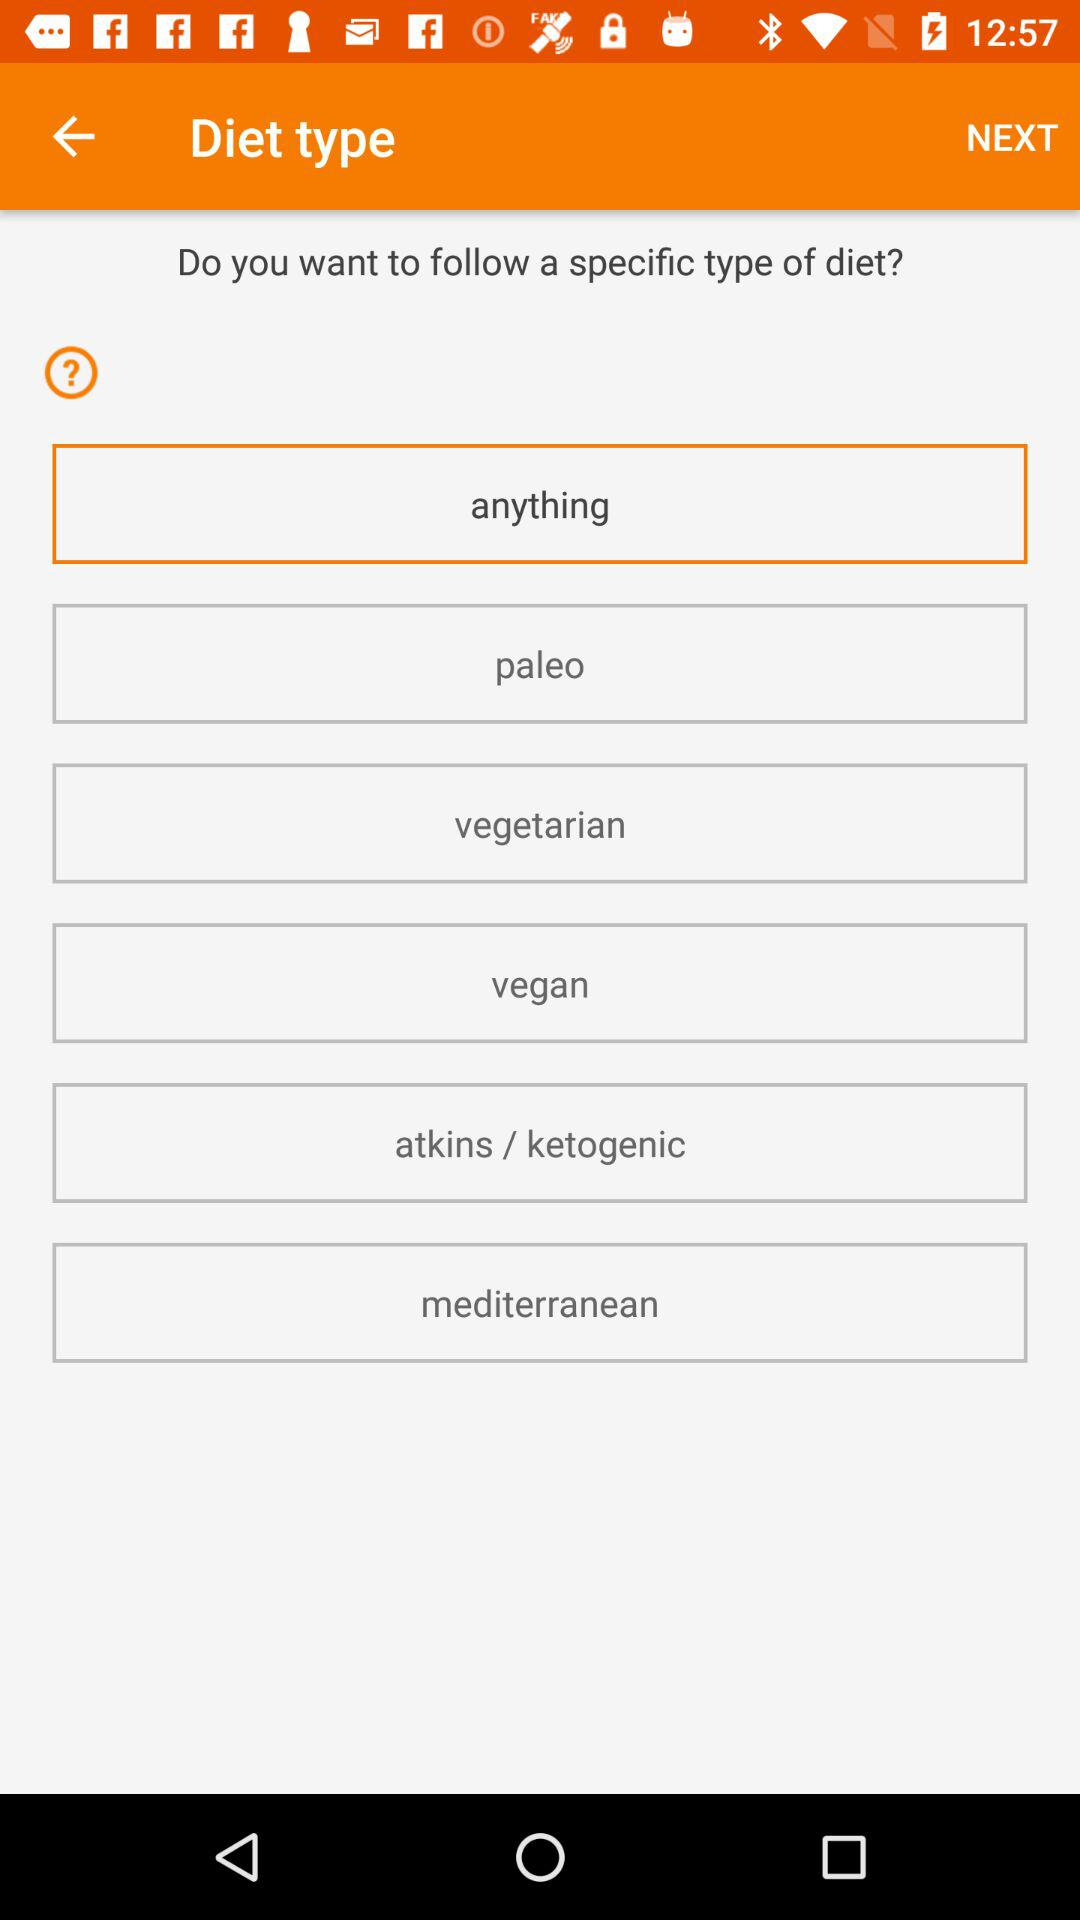How many diet types are there to choose from?
Answer the question using a single word or phrase. 6 